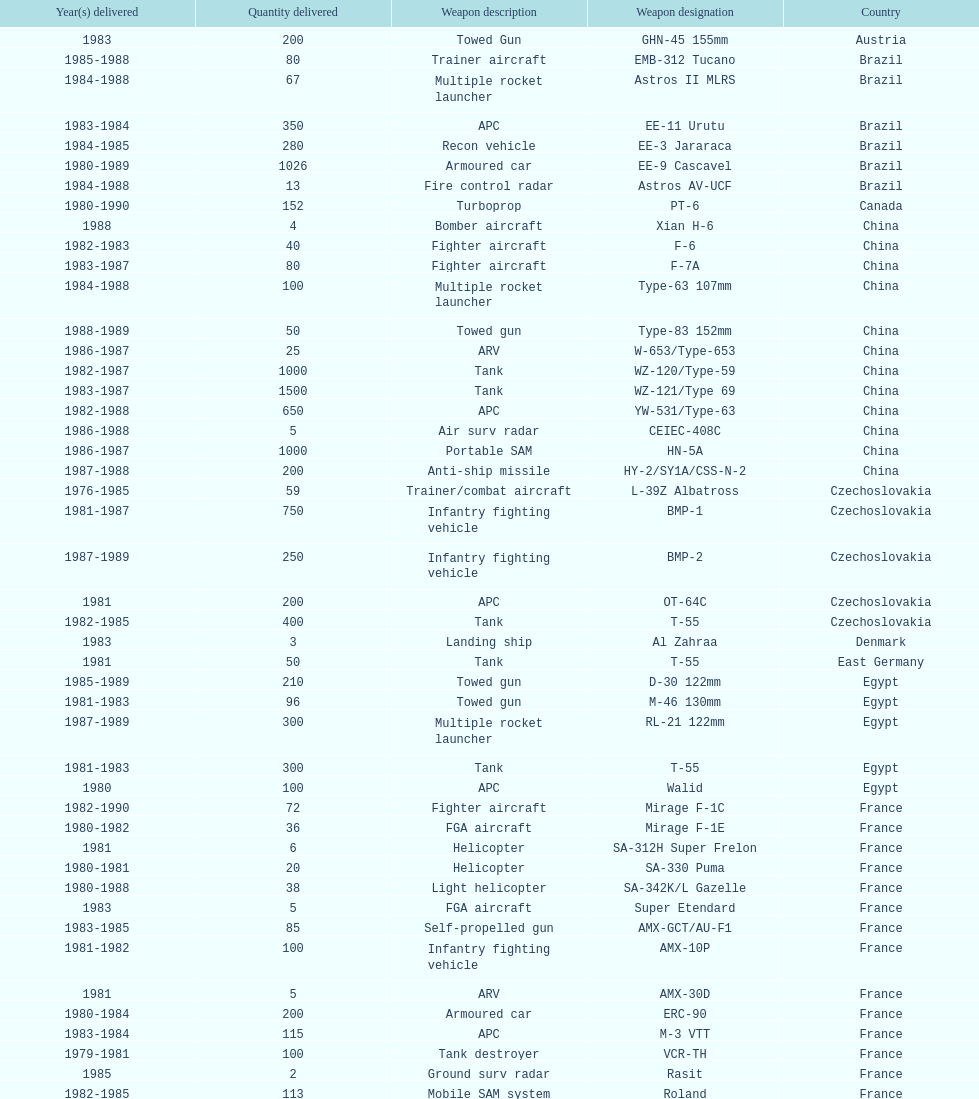Could you help me parse every detail presented in this table? {'header': ['Year(s) delivered', 'Quantity delivered', 'Weapon description', 'Weapon designation', 'Country'], 'rows': [['1983', '200', 'Towed Gun', 'GHN-45 155mm', 'Austria'], ['1985-1988', '80', 'Trainer aircraft', 'EMB-312 Tucano', 'Brazil'], ['1984-1988', '67', 'Multiple rocket launcher', 'Astros II MLRS', 'Brazil'], ['1983-1984', '350', 'APC', 'EE-11 Urutu', 'Brazil'], ['1984-1985', '280', 'Recon vehicle', 'EE-3 Jararaca', 'Brazil'], ['1980-1989', '1026', 'Armoured car', 'EE-9 Cascavel', 'Brazil'], ['1984-1988', '13', 'Fire control radar', 'Astros AV-UCF', 'Brazil'], ['1980-1990', '152', 'Turboprop', 'PT-6', 'Canada'], ['1988', '4', 'Bomber aircraft', 'Xian H-6', 'China'], ['1982-1983', '40', 'Fighter aircraft', 'F-6', 'China'], ['1983-1987', '80', 'Fighter aircraft', 'F-7A', 'China'], ['1984-1988', '100', 'Multiple rocket launcher', 'Type-63 107mm', 'China'], ['1988-1989', '50', 'Towed gun', 'Type-83 152mm', 'China'], ['1986-1987', '25', 'ARV', 'W-653/Type-653', 'China'], ['1982-1987', '1000', 'Tank', 'WZ-120/Type-59', 'China'], ['1983-1987', '1500', 'Tank', 'WZ-121/Type 69', 'China'], ['1982-1988', '650', 'APC', 'YW-531/Type-63', 'China'], ['1986-1988', '5', 'Air surv radar', 'CEIEC-408C', 'China'], ['1986-1987', '1000', 'Portable SAM', 'HN-5A', 'China'], ['1987-1988', '200', 'Anti-ship missile', 'HY-2/SY1A/CSS-N-2', 'China'], ['1976-1985', '59', 'Trainer/combat aircraft', 'L-39Z Albatross', 'Czechoslovakia'], ['1981-1987', '750', 'Infantry fighting vehicle', 'BMP-1', 'Czechoslovakia'], ['1987-1989', '250', 'Infantry fighting vehicle', 'BMP-2', 'Czechoslovakia'], ['1981', '200', 'APC', 'OT-64C', 'Czechoslovakia'], ['1982-1985', '400', 'Tank', 'T-55', 'Czechoslovakia'], ['1983', '3', 'Landing ship', 'Al Zahraa', 'Denmark'], ['1981', '50', 'Tank', 'T-55', 'East Germany'], ['1985-1989', '210', 'Towed gun', 'D-30 122mm', 'Egypt'], ['1981-1983', '96', 'Towed gun', 'M-46 130mm', 'Egypt'], ['1987-1989', '300', 'Multiple rocket launcher', 'RL-21 122mm', 'Egypt'], ['1981-1983', '300', 'Tank', 'T-55', 'Egypt'], ['1980', '100', 'APC', 'Walid', 'Egypt'], ['1982-1990', '72', 'Fighter aircraft', 'Mirage F-1C', 'France'], ['1980-1982', '36', 'FGA aircraft', 'Mirage F-1E', 'France'], ['1981', '6', 'Helicopter', 'SA-312H Super Frelon', 'France'], ['1980-1981', '20', 'Helicopter', 'SA-330 Puma', 'France'], ['1980-1988', '38', 'Light helicopter', 'SA-342K/L Gazelle', 'France'], ['1983', '5', 'FGA aircraft', 'Super Etendard', 'France'], ['1983-1985', '85', 'Self-propelled gun', 'AMX-GCT/AU-F1', 'France'], ['1981-1982', '100', 'Infantry fighting vehicle', 'AMX-10P', 'France'], ['1981', '5', 'ARV', 'AMX-30D', 'France'], ['1980-1984', '200', 'Armoured car', 'ERC-90', 'France'], ['1983-1984', '115', 'APC', 'M-3 VTT', 'France'], ['1979-1981', '100', 'Tank destroyer', 'VCR-TH', 'France'], ['1985', '2', 'Ground surv radar', 'Rasit', 'France'], ['1982-1985', '113', 'Mobile SAM system', 'Roland', 'France'], ['1988', '1', 'Air surv radar', 'TRS-2100 Tiger', 'France'], ['1986-1989', '5', 'Air surv radar', 'TRS-2105/6 Tiger-G', 'France'], ['1984-1985', '6', 'Air surv radar', 'TRS-2230/15 Tiger', 'France'], ['1981-1983', '5', 'Air surv radar', 'Volex', 'France'], ['1979-1988', '352', 'Anti-ship missile', 'AM-39 Exocet', 'France'], ['1986-1990', '450', 'Anti-radar missile', 'ARMAT', 'France'], ['1986-1990', '240', 'ASM', 'AS-30L', 'France'], ['1981-1982', '1000', 'Anti-tank missile', 'HOT', 'France'], ['1981-1985', '534', 'SRAAM', 'R-550 Magic-1', 'France'], ['1981-1990', '2260', 'SAM', 'Roland-2', 'France'], ['1981-1985', '300', 'BVRAAM', 'Super 530F', 'France'], ['1984-1989', '22', 'Helicopter', 'BK-117', 'West Germany'], ['1979-1982', '20', 'Light Helicopter', 'Bo-105C', 'West Germany'], ['1988', '6', 'Light Helicopter', 'Bo-105L', 'West Germany'], ['1981', '300', 'APC', 'PSZH-D-994', 'Hungary'], ['1982', '2', 'Light Helicopter', 'A-109 Hirundo', 'Italy'], ['1982', '6', 'Helicopter', 'S-61', 'Italy'], ['1981', '1', 'Support ship', 'Stromboli class', 'Italy'], ['1985', '2', 'Helicopter', 'S-76 Spirit', 'Jordan'], ['1984-1985', '15', 'Helicopter', 'Mi-2/Hoplite', 'Poland'], ['1983-1990', '750', 'APC', 'MT-LB', 'Poland'], ['1981-1982', '400', 'Tank', 'T-55', 'Poland'], ['1982-1990', '500', 'Tank', 'T-72M1', 'Poland'], ['1982-1984', '150', 'Tank', 'T-55', 'Romania'], ['1988', '2', 'Multiple rocket launcher', 'M-87 Orkan 262mm', 'Yugoslavia'], ['1985-1988', '200', 'Towed gun', 'G-5 155mm', 'South Africa'], ['1980-1983', '52', 'Trainer aircraft', 'PC-7 Turbo trainer', 'Switzerland'], ['1987-1990', '20', 'Trainer aircraft', 'PC-9', 'Switzerland'], ['1981', '100', 'APC/IFV', 'Roland', 'Switzerland'], ['1982', '29', 'ARV', 'Chieftain/ARV', 'United Kingdom'], ['1986-1988', '10', 'Arty locating radar', 'Cymbeline', 'United Kingdom'], ['1983', '30', 'Light Helicopter', 'MD-500MD Defender', 'United States'], ['1983', '30', 'Light Helicopter', 'Hughes-300/TH-55', 'United States'], ['1986', '26', 'Light Helicopter', 'MD-530F', 'United States'], ['1988', '31', 'Helicopter', 'Bell 214ST', 'United States'], ['1978-1984', '33', 'Strategic airlifter', 'Il-76M/Candid-B', 'Soviet Union'], ['1978-1984', '12', 'Attack helicopter', 'Mi-24D/Mi-25/Hind-D', 'Soviet Union'], ['1986-1987', '37', 'Transport helicopter', 'Mi-8/Mi-17/Hip-H', 'Soviet Union'], ['1984', '30', 'Transport helicopter', 'Mi-8TV/Hip-F', 'Soviet Union'], ['1983-1984', '61', 'Fighter aircraft', 'Mig-21bis/Fishbed-N', 'Soviet Union'], ['1984-1985', '50', 'FGA aircraft', 'Mig-23BN/Flogger-H', 'Soviet Union'], ['1980-1985', '55', 'Interceptor aircraft', 'Mig-25P/Foxbat-A', 'Soviet Union'], ['1982', '8', 'Recon aircraft', 'Mig-25RB/Foxbat-B', 'Soviet Union'], ['1986-1989', '41', 'Fighter aircraft', 'Mig-29/Fulcrum-A', 'Soviet Union'], ['1986-1987', '61', 'FGA aircraft', 'Su-22/Fitter-H/J/K', 'Soviet Union'], ['1986-1987', '84', 'Ground attack aircraft', 'Su-25/Frogfoot-A', 'Soviet Union'], ['1986-1988', '180', 'Towed gun', '2A36 152mm', 'Soviet Union'], ['1980-1989', '150', 'Self-Propelled Howitzer', '2S1 122mm', 'Soviet Union'], ['1980-1989', '150', 'Self-propelled gun', '2S3 152mm', 'Soviet Union'], ['1983', '10', 'Self-propelled mortar', '2S4 240mm', 'Soviet Union'], ['1983-1984', '10', 'SSM launcher', '9P117/SS-1 Scud TEL', 'Soviet Union'], ['1983-1988', '560', 'Multiple rocket launcher', 'BM-21 Grad 122mm', 'Soviet Union'], ['1982-1988', '576', 'Towed gun', 'D-30 122mm', 'Soviet Union'], ['1981', '25', 'Mortar', 'M-240 240mm', 'Soviet Union'], ['1982-1987', '576', 'Towed Gun', 'M-46 130mm', 'Soviet Union'], ['1985', '30', 'AAV(M)', '9K35 Strela-10/SA-13', 'Soviet Union'], ['1981', '10', 'IFV', 'BMD-1', 'Soviet Union'], ['1984', '200', 'Light tank', 'PT-76', 'Soviet Union'], ['1982-1985', '160', 'AAV(M)', 'SA-9/9P31', 'Soviet Union'], ['1980-1984', '10', 'Air surv radar', 'Long Track', 'Soviet Union'], ['1982-1985', '50', 'Mobile SAM system', 'SA-8b/9K33M Osa AK', 'Soviet Union'], ['1980-1984', '5', 'Air surv radar', 'Thin Skin', 'Soviet Union'], ['1986-1989', '3000', 'Anti-tank missile', '9M111/AT-4 Spigot', 'Soviet Union'], ['1985-1986', '960', 'SAM', '9M37/SA-13 Gopher', 'Soviet Union'], ['1984', '36', 'Anti-ship missile', 'KSR-5/AS-6 Kingfish', 'Soviet Union'], ['1983-1988', '250', 'Anti-radar missile', 'Kh-28/AS-9 Kyle', 'Soviet Union'], ['1984-1987', '1080', 'SRAAM', 'R-13S/AA2S Atoll', 'Soviet Union'], ['1982-1988', '840', 'SSM', 'R-17/SS-1c Scud-B', 'Soviet Union'], ['1986-1989', '246', 'BVRAAM', 'R-27/AA-10 Alamo', 'Soviet Union'], ['1980-1985', '660', 'BVRAAM', 'R-40R/AA-6 Acrid', 'Soviet Union'], ['1986-1989', '582', 'SRAAM', 'R-60/AA-8 Aphid', 'Soviet Union'], ['1982-1985', '1290', 'SAM', 'SA-8b Gecko/9M33M', 'Soviet Union'], ['1982-1985', '1920', 'SAM', 'SA-9 Gaskin/9M31', 'Soviet Union'], ['1987-1988', '500', 'Portable SAM', 'Strela-3/SA-14 Gremlin', 'Soviet Union']]} According to this list, how many countries sold weapons to iraq? 21. 